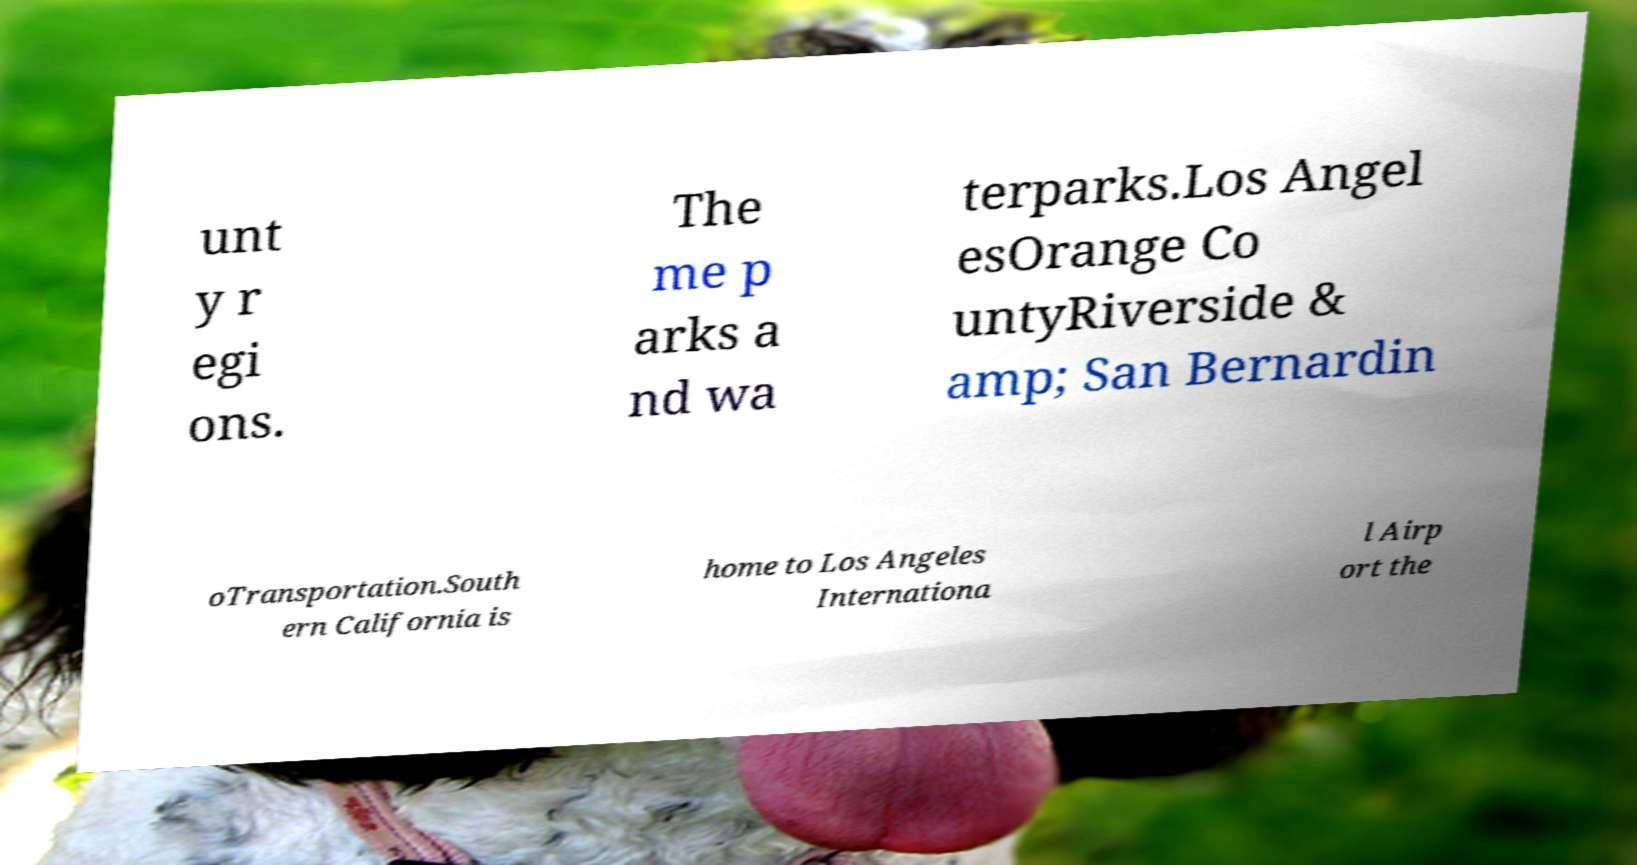Could you assist in decoding the text presented in this image and type it out clearly? unt y r egi ons. The me p arks a nd wa terparks.Los Angel esOrange Co untyRiverside & amp; San Bernardin oTransportation.South ern California is home to Los Angeles Internationa l Airp ort the 